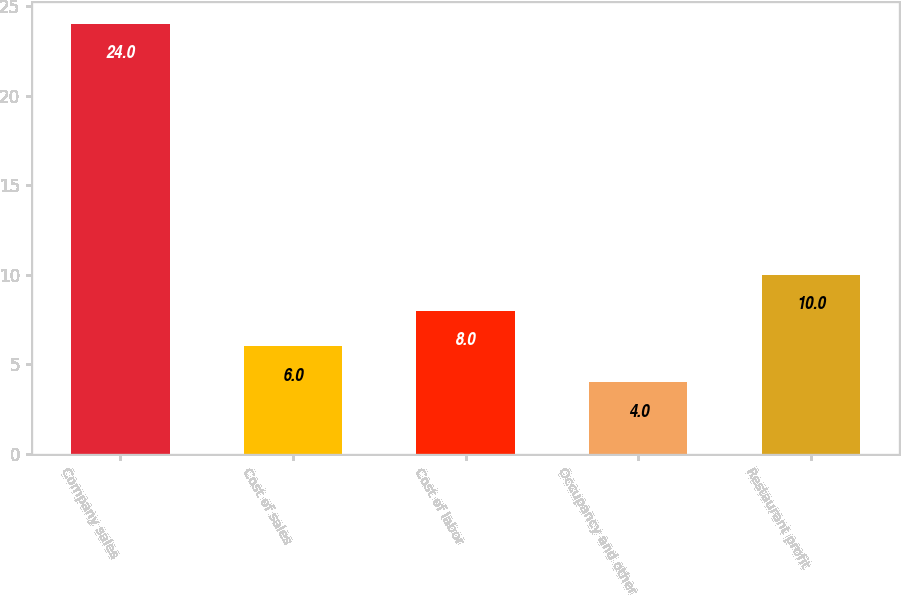Convert chart. <chart><loc_0><loc_0><loc_500><loc_500><bar_chart><fcel>Company sales<fcel>Cost of sales<fcel>Cost of labor<fcel>Occupancy and other<fcel>Restaurant profit<nl><fcel>24<fcel>6<fcel>8<fcel>4<fcel>10<nl></chart> 